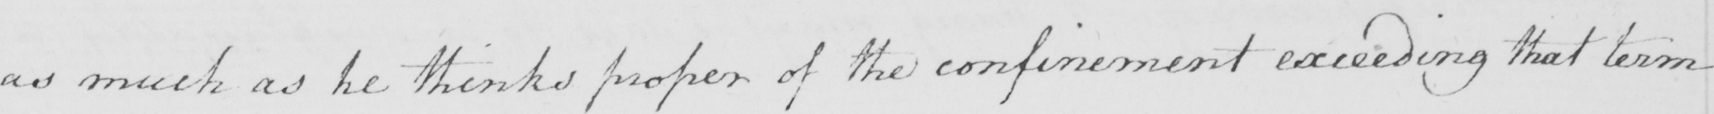Transcribe the text shown in this historical manuscript line. as much as he thinks proper of the confinement exceeding that term 